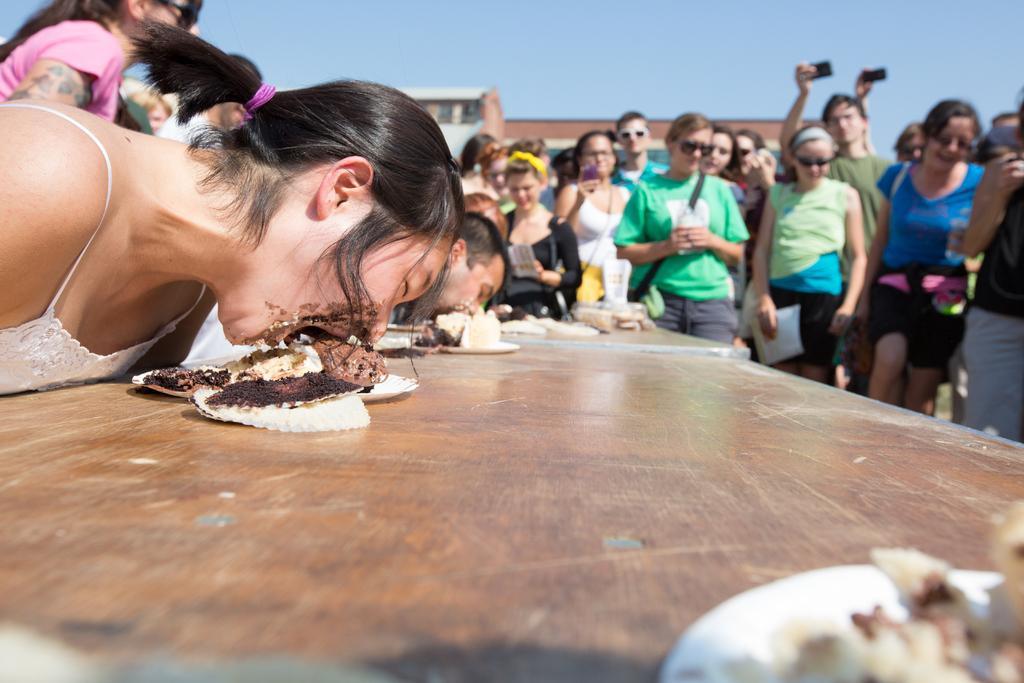Please provide a concise description of this image. In this picture there are people, among them there are two people eating food items which are on plates on the table. In the background of the image we can see building and sky. 